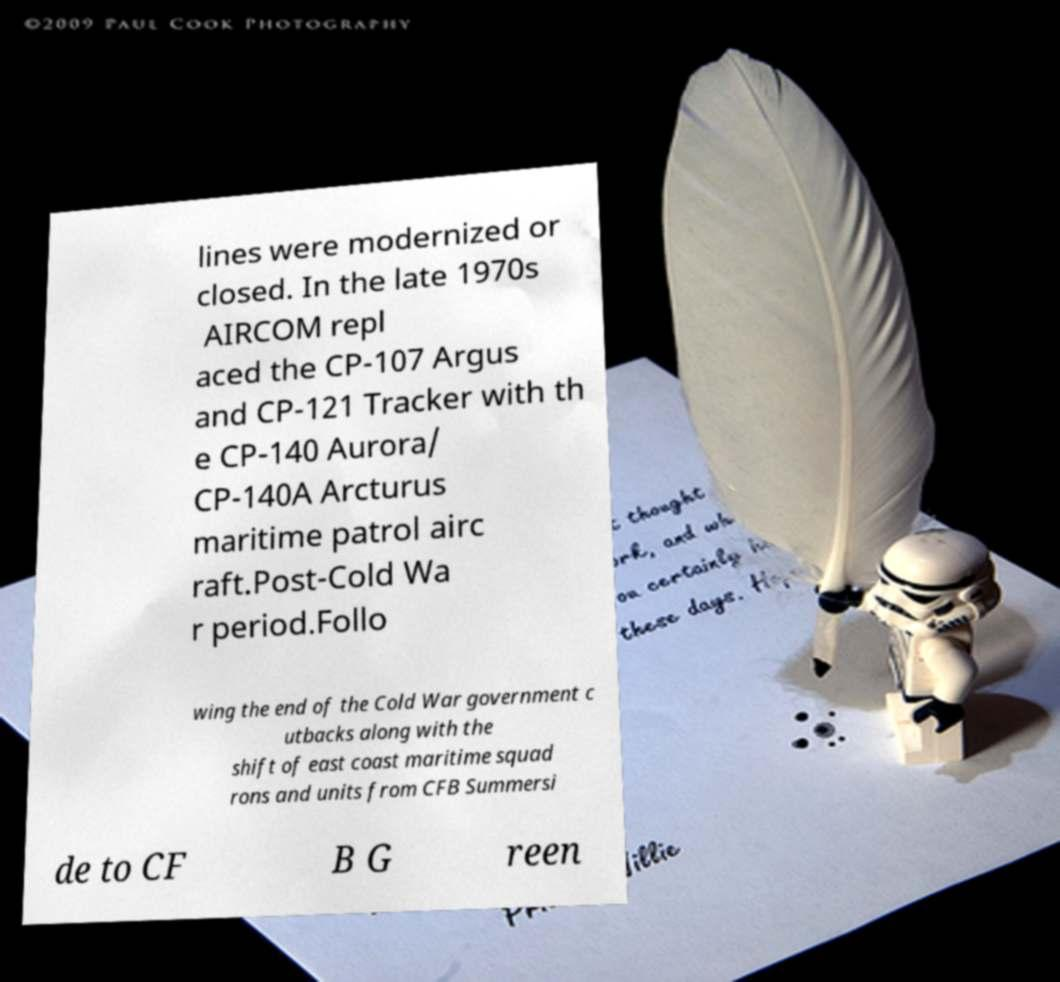There's text embedded in this image that I need extracted. Can you transcribe it verbatim? lines were modernized or closed. In the late 1970s AIRCOM repl aced the CP-107 Argus and CP-121 Tracker with th e CP-140 Aurora/ CP-140A Arcturus maritime patrol airc raft.Post-Cold Wa r period.Follo wing the end of the Cold War government c utbacks along with the shift of east coast maritime squad rons and units from CFB Summersi de to CF B G reen 